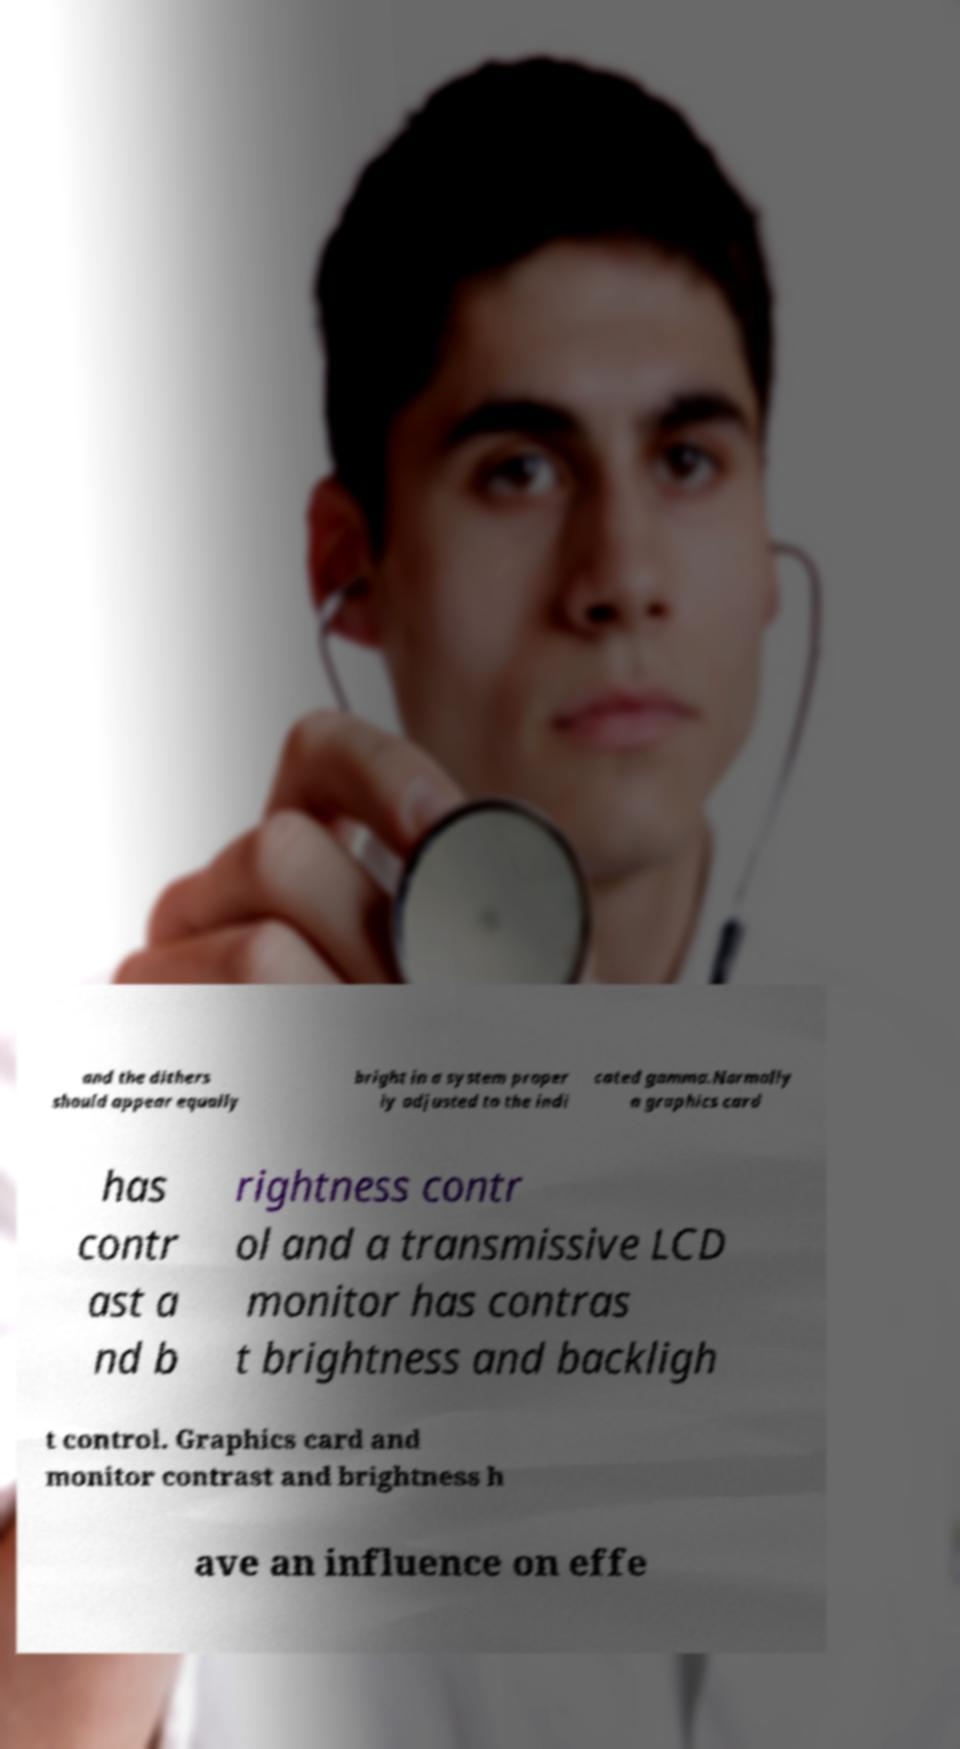Could you extract and type out the text from this image? and the dithers should appear equally bright in a system proper ly adjusted to the indi cated gamma.Normally a graphics card has contr ast a nd b rightness contr ol and a transmissive LCD monitor has contras t brightness and backligh t control. Graphics card and monitor contrast and brightness h ave an influence on effe 